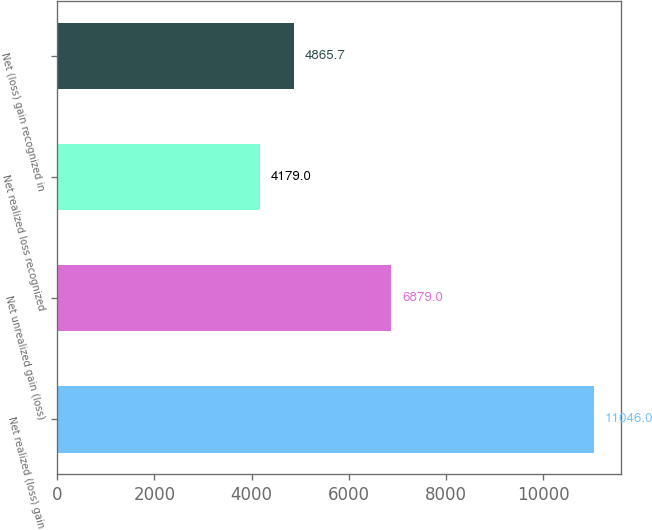<chart> <loc_0><loc_0><loc_500><loc_500><bar_chart><fcel>Net realized (loss) gain<fcel>Net unrealized gain (loss)<fcel>Net realized loss recognized<fcel>Net (loss) gain recognized in<nl><fcel>11046<fcel>6879<fcel>4179<fcel>4865.7<nl></chart> 